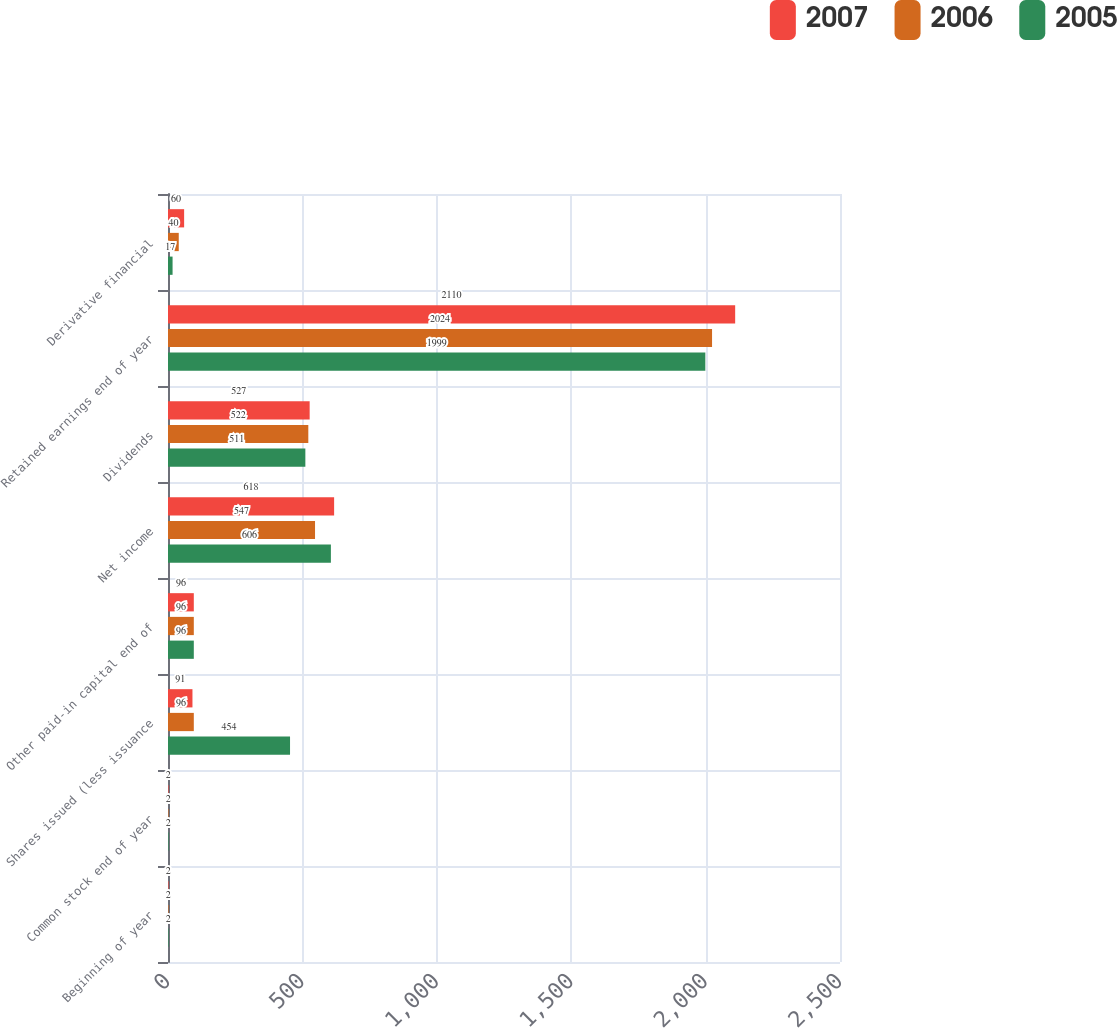Convert chart. <chart><loc_0><loc_0><loc_500><loc_500><stacked_bar_chart><ecel><fcel>Beginning of year<fcel>Common stock end of year<fcel>Shares issued (less issuance<fcel>Other paid-in capital end of<fcel>Net income<fcel>Dividends<fcel>Retained earnings end of year<fcel>Derivative financial<nl><fcel>2007<fcel>2<fcel>2<fcel>91<fcel>96<fcel>618<fcel>527<fcel>2110<fcel>60<nl><fcel>2006<fcel>2<fcel>2<fcel>96<fcel>96<fcel>547<fcel>522<fcel>2024<fcel>40<nl><fcel>2005<fcel>2<fcel>2<fcel>454<fcel>96<fcel>606<fcel>511<fcel>1999<fcel>17<nl></chart> 